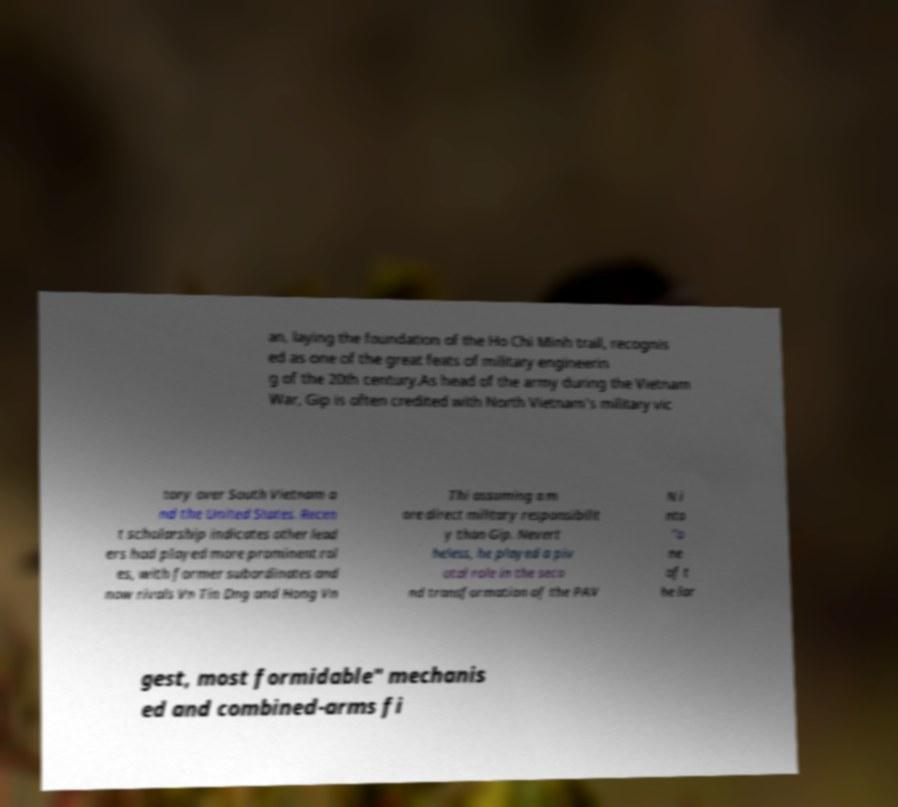For documentation purposes, I need the text within this image transcribed. Could you provide that? an, laying the foundation of the Ho Chi Minh trail, recognis ed as one of the great feats of military engineerin g of the 20th century.As head of the army during the Vietnam War, Gip is often credited with North Vietnam's military vic tory over South Vietnam a nd the United States. Recen t scholarship indicates other lead ers had played more prominent rol es, with former subordinates and now rivals Vn Tin Dng and Hong Vn Thi assuming a m ore direct military responsibilit y than Gip. Nevert heless, he played a piv otal role in the seco nd transformation of the PAV N i nto "o ne of t he lar gest, most formidable" mechanis ed and combined-arms fi 